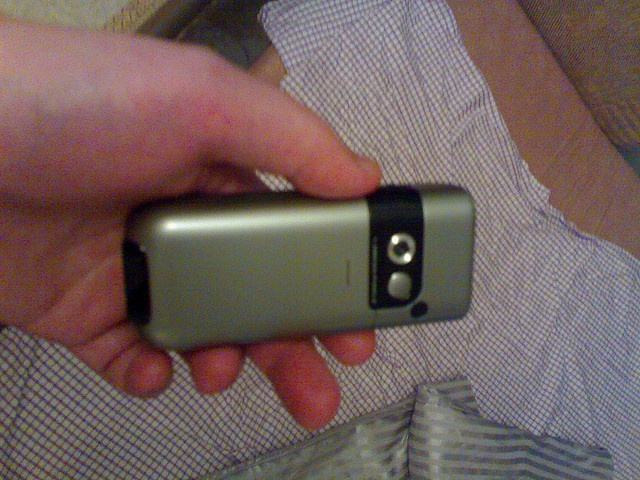Describe the objects in this image and their specific colors. I can see people in gray, brown, maroon, and purple tones and cell phone in gray, black, darkgreen, and darkgray tones in this image. 